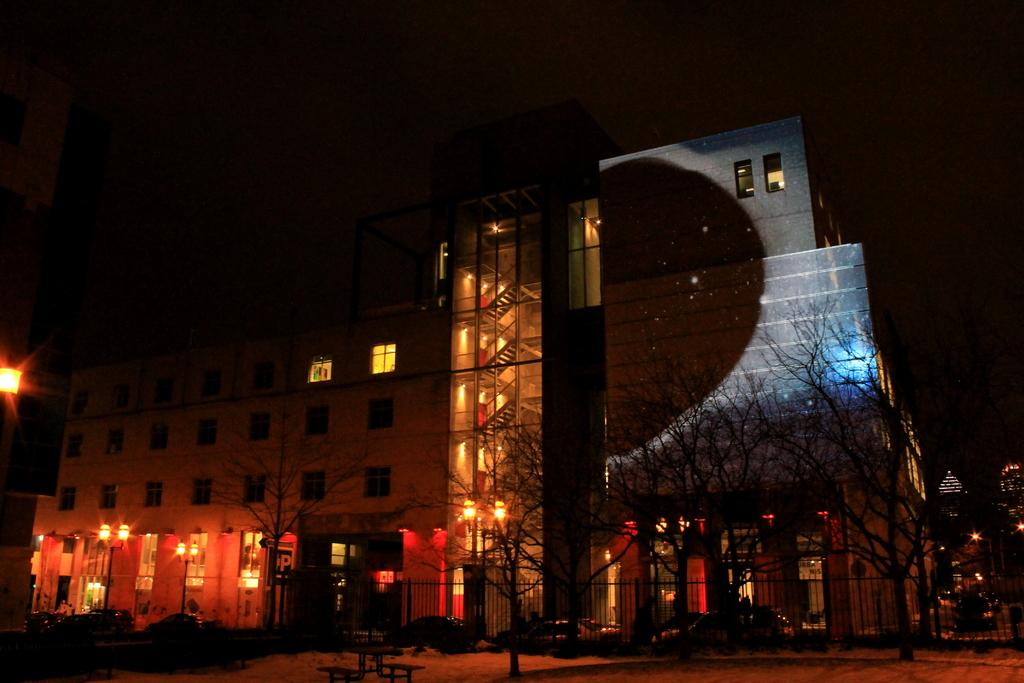What type of structures can be seen in the image? There are buildings in the image. What other natural elements are present in the image? There are trees in the image. What are the light sources in the image? There are light poles in the image. What type of vehicles can be seen in the image? Cars are present in the image. What type of barrier is visible in the image? There is a fence visible in the image. What type of seating is available in the image? A bench is visible in the image. What type of notebook is being used by the cart in the image? There is no notebook or cart present in the image. How does the reaction of the trees affect the light poles in the image? There are no reactions or emotions attributed to the trees or light poles in the image; they are inanimate objects. 